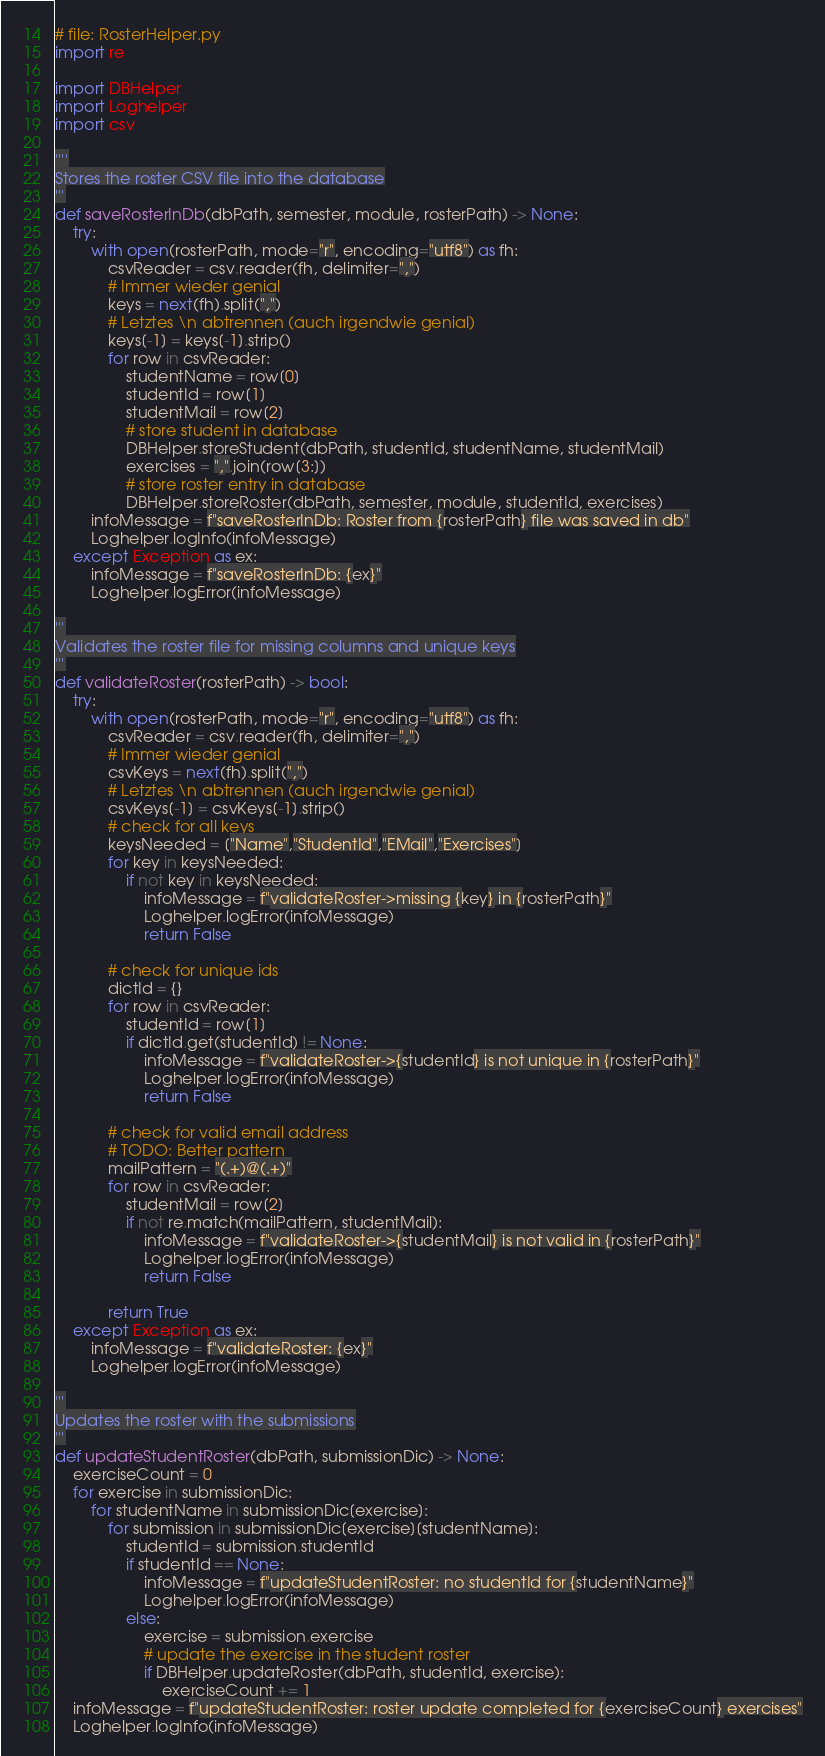Convert code to text. <code><loc_0><loc_0><loc_500><loc_500><_Python_># file: RosterHelper.py
import re

import DBHelper
import Loghelper
import csv

''''
Stores the roster CSV file into the database
'''
def saveRosterInDb(dbPath, semester, module, rosterPath) -> None:
    try:
        with open(rosterPath, mode="r", encoding="utf8") as fh:
            csvReader = csv.reader(fh, delimiter=",")
            # Immer wieder genial
            keys = next(fh).split(",")
            # Letztes \n abtrennen (auch irgendwie genial)
            keys[-1] = keys[-1].strip()
            for row in csvReader:
                studentName = row[0]
                studentId = row[1]
                studentMail = row[2]
                # store student in database
                DBHelper.storeStudent(dbPath, studentId, studentName, studentMail)
                exercises = ",".join(row[3:])
                # store roster entry in database
                DBHelper.storeRoster(dbPath, semester, module, studentId, exercises)
        infoMessage = f"saveRosterInDb: Roster from {rosterPath} file was saved in db"
        Loghelper.logInfo(infoMessage)
    except Exception as ex:
        infoMessage = f"saveRosterInDb: {ex}"
        Loghelper.logError(infoMessage)

'''
Validates the roster file for missing columns and unique keys
'''
def validateRoster(rosterPath) -> bool:
    try:
        with open(rosterPath, mode="r", encoding="utf8") as fh:
            csvReader = csv.reader(fh, delimiter=",")
            # Immer wieder genial
            csvKeys = next(fh).split(",")
            # Letztes \n abtrennen (auch irgendwie genial)
            csvKeys[-1] = csvKeys[-1].strip()
            # check for all keys
            keysNeeded = ["Name","StudentId","EMail","Exercises"]
            for key in keysNeeded:
                if not key in keysNeeded:
                    infoMessage = f"validateRoster->missing {key} in {rosterPath}"
                    Loghelper.logError(infoMessage)
                    return False

            # check for unique ids
            dictId = {}
            for row in csvReader:
                studentId = row[1]
                if dictId.get(studentId) != None:
                    infoMessage = f"validateRoster->{studentId} is not unique in {rosterPath}"
                    Loghelper.logError(infoMessage)
                    return False

            # check for valid email address
            # TODO: Better pattern
            mailPattern = "(.+)@(.+)"
            for row in csvReader:
                studentMail = row[2]
                if not re.match(mailPattern, studentMail):
                    infoMessage = f"validateRoster->{studentMail} is not valid in {rosterPath}"
                    Loghelper.logError(infoMessage)
                    return False

            return True
    except Exception as ex:
        infoMessage = f"validateRoster: {ex}"
        Loghelper.logError(infoMessage)

'''
Updates the roster with the submissions
'''
def updateStudentRoster(dbPath, submissionDic) -> None:
    exerciseCount = 0
    for exercise in submissionDic:
        for studentName in submissionDic[exercise]:
            for submission in submissionDic[exercise][studentName]:
                studentId = submission.studentId
                if studentId == None:
                    infoMessage = f"updateStudentRoster: no studentId for {studentName}"
                    Loghelper.logError(infoMessage)
                else:
                    exercise = submission.exercise
                    # update the exercise in the student roster
                    if DBHelper.updateRoster(dbPath, studentId, exercise):
                        exerciseCount += 1
    infoMessage = f"updateStudentRoster: roster update completed for {exerciseCount} exercises"
    Loghelper.logInfo(infoMessage)

</code> 